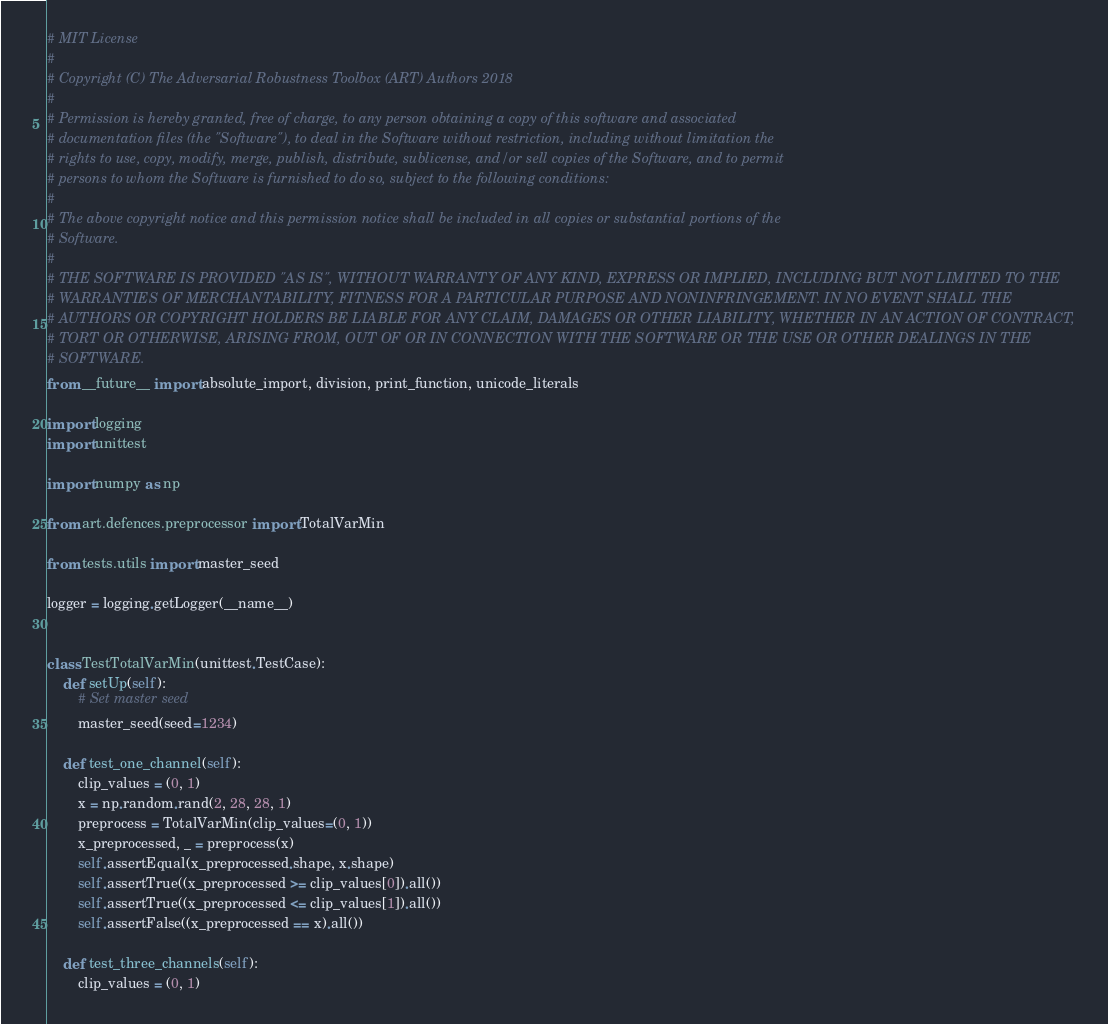<code> <loc_0><loc_0><loc_500><loc_500><_Python_># MIT License
#
# Copyright (C) The Adversarial Robustness Toolbox (ART) Authors 2018
#
# Permission is hereby granted, free of charge, to any person obtaining a copy of this software and associated
# documentation files (the "Software"), to deal in the Software without restriction, including without limitation the
# rights to use, copy, modify, merge, publish, distribute, sublicense, and/or sell copies of the Software, and to permit
# persons to whom the Software is furnished to do so, subject to the following conditions:
#
# The above copyright notice and this permission notice shall be included in all copies or substantial portions of the
# Software.
#
# THE SOFTWARE IS PROVIDED "AS IS", WITHOUT WARRANTY OF ANY KIND, EXPRESS OR IMPLIED, INCLUDING BUT NOT LIMITED TO THE
# WARRANTIES OF MERCHANTABILITY, FITNESS FOR A PARTICULAR PURPOSE AND NONINFRINGEMENT. IN NO EVENT SHALL THE
# AUTHORS OR COPYRIGHT HOLDERS BE LIABLE FOR ANY CLAIM, DAMAGES OR OTHER LIABILITY, WHETHER IN AN ACTION OF CONTRACT,
# TORT OR OTHERWISE, ARISING FROM, OUT OF OR IN CONNECTION WITH THE SOFTWARE OR THE USE OR OTHER DEALINGS IN THE
# SOFTWARE.
from __future__ import absolute_import, division, print_function, unicode_literals

import logging
import unittest

import numpy as np

from art.defences.preprocessor import TotalVarMin

from tests.utils import master_seed

logger = logging.getLogger(__name__)


class TestTotalVarMin(unittest.TestCase):
    def setUp(self):
        # Set master seed
        master_seed(seed=1234)

    def test_one_channel(self):
        clip_values = (0, 1)
        x = np.random.rand(2, 28, 28, 1)
        preprocess = TotalVarMin(clip_values=(0, 1))
        x_preprocessed, _ = preprocess(x)
        self.assertEqual(x_preprocessed.shape, x.shape)
        self.assertTrue((x_preprocessed >= clip_values[0]).all())
        self.assertTrue((x_preprocessed <= clip_values[1]).all())
        self.assertFalse((x_preprocessed == x).all())

    def test_three_channels(self):
        clip_values = (0, 1)</code> 